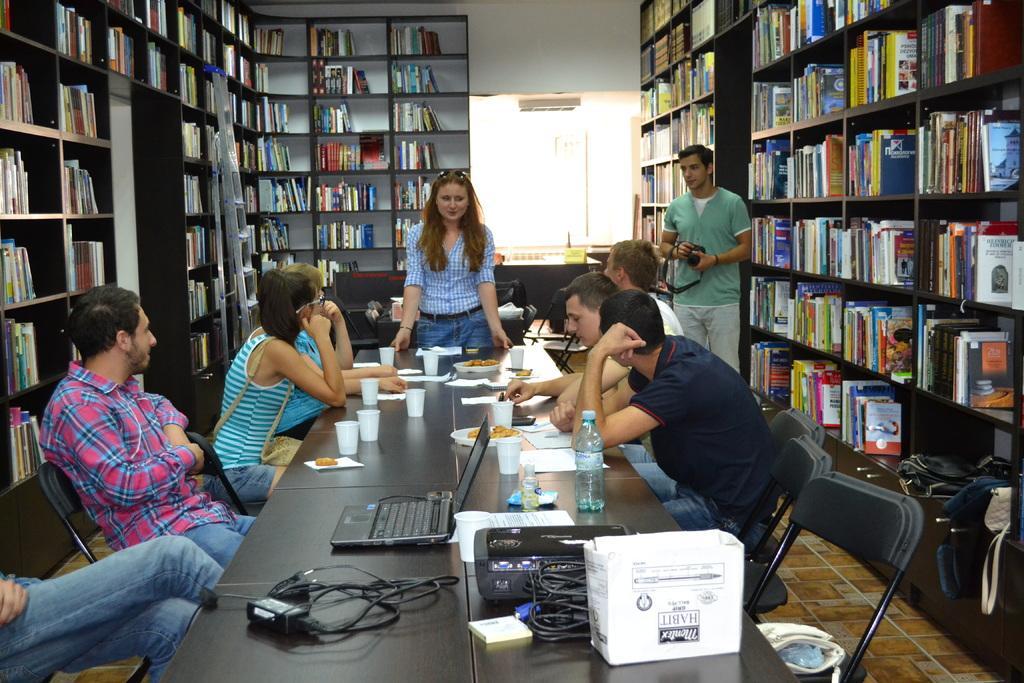How would you summarize this image in a sentence or two? In this image, there are a few people. Among them, some people are sitting and some people are standing. We can see a table with some objects like devices, wires, glasses and some food items. We can also see some chairs. We can see some shelves with objects like books. We can see the ground. We can also see the wall with some objects. 